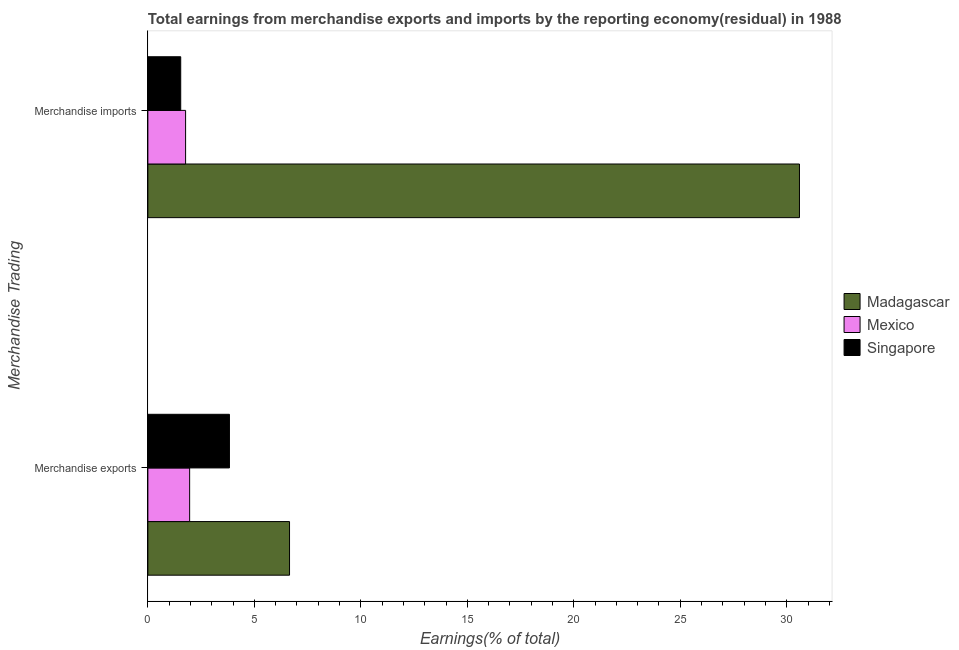How many different coloured bars are there?
Your answer should be very brief. 3. Are the number of bars per tick equal to the number of legend labels?
Make the answer very short. Yes. How many bars are there on the 2nd tick from the top?
Offer a very short reply. 3. What is the earnings from merchandise imports in Mexico?
Provide a short and direct response. 1.77. Across all countries, what is the maximum earnings from merchandise imports?
Make the answer very short. 30.6. Across all countries, what is the minimum earnings from merchandise imports?
Keep it short and to the point. 1.54. In which country was the earnings from merchandise exports maximum?
Keep it short and to the point. Madagascar. In which country was the earnings from merchandise exports minimum?
Offer a terse response. Mexico. What is the total earnings from merchandise imports in the graph?
Keep it short and to the point. 33.91. What is the difference between the earnings from merchandise exports in Madagascar and that in Mexico?
Your response must be concise. 4.69. What is the difference between the earnings from merchandise exports in Mexico and the earnings from merchandise imports in Madagascar?
Provide a succinct answer. -28.64. What is the average earnings from merchandise exports per country?
Provide a short and direct response. 4.15. What is the difference between the earnings from merchandise exports and earnings from merchandise imports in Madagascar?
Your response must be concise. -23.95. What is the ratio of the earnings from merchandise exports in Singapore to that in Madagascar?
Provide a succinct answer. 0.58. Is the earnings from merchandise exports in Singapore less than that in Madagascar?
Give a very brief answer. Yes. What does the 1st bar from the top in Merchandise imports represents?
Ensure brevity in your answer.  Singapore. What does the 1st bar from the bottom in Merchandise exports represents?
Your answer should be very brief. Madagascar. Are all the bars in the graph horizontal?
Provide a succinct answer. Yes. What is the difference between two consecutive major ticks on the X-axis?
Your response must be concise. 5. Are the values on the major ticks of X-axis written in scientific E-notation?
Provide a succinct answer. No. Does the graph contain any zero values?
Offer a terse response. No. Does the graph contain grids?
Provide a succinct answer. No. Where does the legend appear in the graph?
Provide a succinct answer. Center right. How many legend labels are there?
Give a very brief answer. 3. What is the title of the graph?
Offer a terse response. Total earnings from merchandise exports and imports by the reporting economy(residual) in 1988. What is the label or title of the X-axis?
Your response must be concise. Earnings(% of total). What is the label or title of the Y-axis?
Offer a terse response. Merchandise Trading. What is the Earnings(% of total) in Madagascar in Merchandise exports?
Keep it short and to the point. 6.65. What is the Earnings(% of total) of Mexico in Merchandise exports?
Your response must be concise. 1.96. What is the Earnings(% of total) in Singapore in Merchandise exports?
Keep it short and to the point. 3.83. What is the Earnings(% of total) in Madagascar in Merchandise imports?
Your answer should be very brief. 30.6. What is the Earnings(% of total) in Mexico in Merchandise imports?
Provide a short and direct response. 1.77. What is the Earnings(% of total) of Singapore in Merchandise imports?
Offer a very short reply. 1.54. Across all Merchandise Trading, what is the maximum Earnings(% of total) of Madagascar?
Your response must be concise. 30.6. Across all Merchandise Trading, what is the maximum Earnings(% of total) of Mexico?
Provide a short and direct response. 1.96. Across all Merchandise Trading, what is the maximum Earnings(% of total) in Singapore?
Provide a short and direct response. 3.83. Across all Merchandise Trading, what is the minimum Earnings(% of total) of Madagascar?
Offer a terse response. 6.65. Across all Merchandise Trading, what is the minimum Earnings(% of total) of Mexico?
Your answer should be compact. 1.77. Across all Merchandise Trading, what is the minimum Earnings(% of total) in Singapore?
Provide a short and direct response. 1.54. What is the total Earnings(% of total) in Madagascar in the graph?
Make the answer very short. 37.25. What is the total Earnings(% of total) of Mexico in the graph?
Keep it short and to the point. 3.73. What is the total Earnings(% of total) in Singapore in the graph?
Your answer should be very brief. 5.37. What is the difference between the Earnings(% of total) of Madagascar in Merchandise exports and that in Merchandise imports?
Offer a terse response. -23.95. What is the difference between the Earnings(% of total) in Mexico in Merchandise exports and that in Merchandise imports?
Give a very brief answer. 0.19. What is the difference between the Earnings(% of total) in Singapore in Merchandise exports and that in Merchandise imports?
Keep it short and to the point. 2.29. What is the difference between the Earnings(% of total) of Madagascar in Merchandise exports and the Earnings(% of total) of Mexico in Merchandise imports?
Your response must be concise. 4.88. What is the difference between the Earnings(% of total) of Madagascar in Merchandise exports and the Earnings(% of total) of Singapore in Merchandise imports?
Your answer should be very brief. 5.11. What is the difference between the Earnings(% of total) in Mexico in Merchandise exports and the Earnings(% of total) in Singapore in Merchandise imports?
Offer a very short reply. 0.42. What is the average Earnings(% of total) in Madagascar per Merchandise Trading?
Your answer should be very brief. 18.62. What is the average Earnings(% of total) in Mexico per Merchandise Trading?
Offer a very short reply. 1.87. What is the average Earnings(% of total) in Singapore per Merchandise Trading?
Keep it short and to the point. 2.69. What is the difference between the Earnings(% of total) of Madagascar and Earnings(% of total) of Mexico in Merchandise exports?
Offer a very short reply. 4.69. What is the difference between the Earnings(% of total) of Madagascar and Earnings(% of total) of Singapore in Merchandise exports?
Offer a very short reply. 2.82. What is the difference between the Earnings(% of total) of Mexico and Earnings(% of total) of Singapore in Merchandise exports?
Make the answer very short. -1.87. What is the difference between the Earnings(% of total) of Madagascar and Earnings(% of total) of Mexico in Merchandise imports?
Your answer should be very brief. 28.83. What is the difference between the Earnings(% of total) of Madagascar and Earnings(% of total) of Singapore in Merchandise imports?
Keep it short and to the point. 29.05. What is the difference between the Earnings(% of total) in Mexico and Earnings(% of total) in Singapore in Merchandise imports?
Provide a short and direct response. 0.23. What is the ratio of the Earnings(% of total) of Madagascar in Merchandise exports to that in Merchandise imports?
Your response must be concise. 0.22. What is the ratio of the Earnings(% of total) in Mexico in Merchandise exports to that in Merchandise imports?
Your answer should be compact. 1.11. What is the ratio of the Earnings(% of total) in Singapore in Merchandise exports to that in Merchandise imports?
Provide a short and direct response. 2.48. What is the difference between the highest and the second highest Earnings(% of total) of Madagascar?
Provide a short and direct response. 23.95. What is the difference between the highest and the second highest Earnings(% of total) in Mexico?
Provide a short and direct response. 0.19. What is the difference between the highest and the second highest Earnings(% of total) of Singapore?
Provide a succinct answer. 2.29. What is the difference between the highest and the lowest Earnings(% of total) in Madagascar?
Your answer should be very brief. 23.95. What is the difference between the highest and the lowest Earnings(% of total) in Mexico?
Provide a short and direct response. 0.19. What is the difference between the highest and the lowest Earnings(% of total) of Singapore?
Provide a short and direct response. 2.29. 